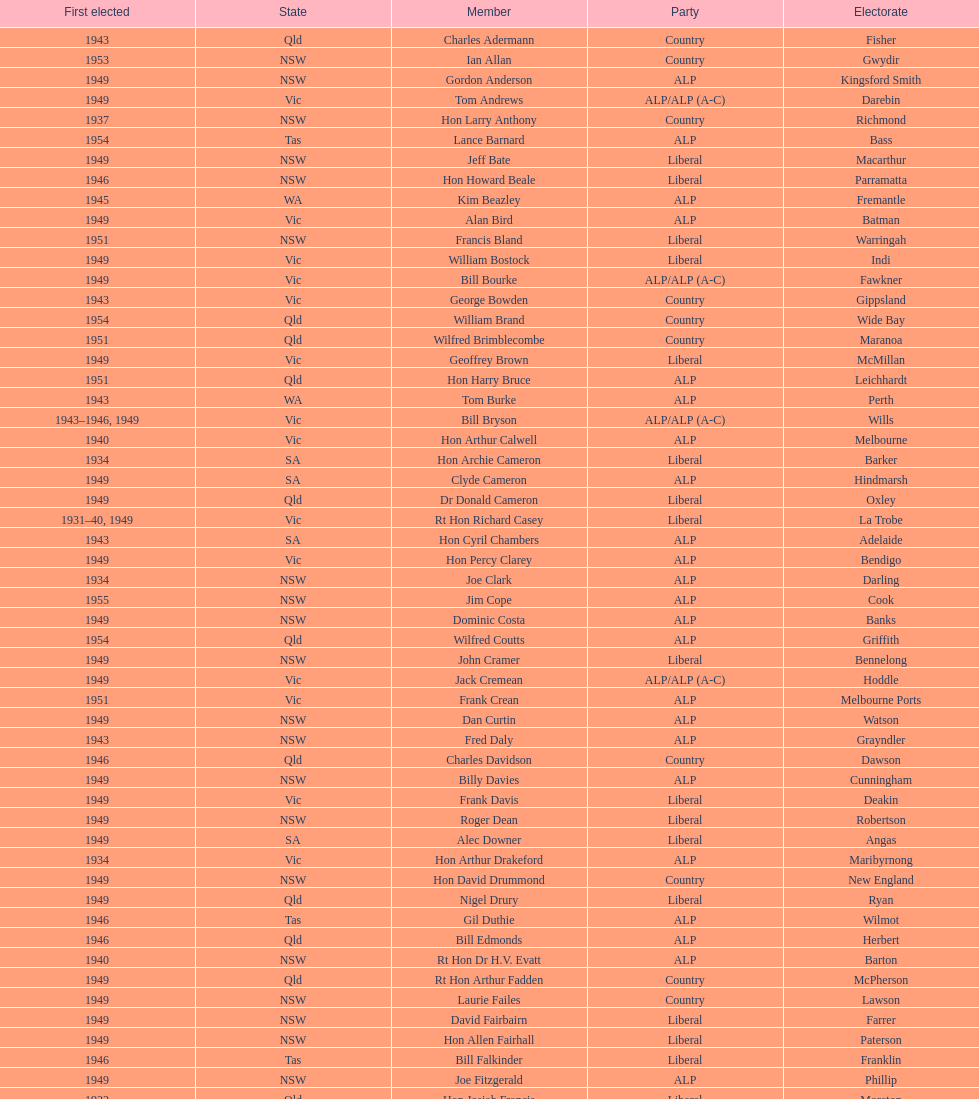Did tom burke run as country or alp party? ALP. 